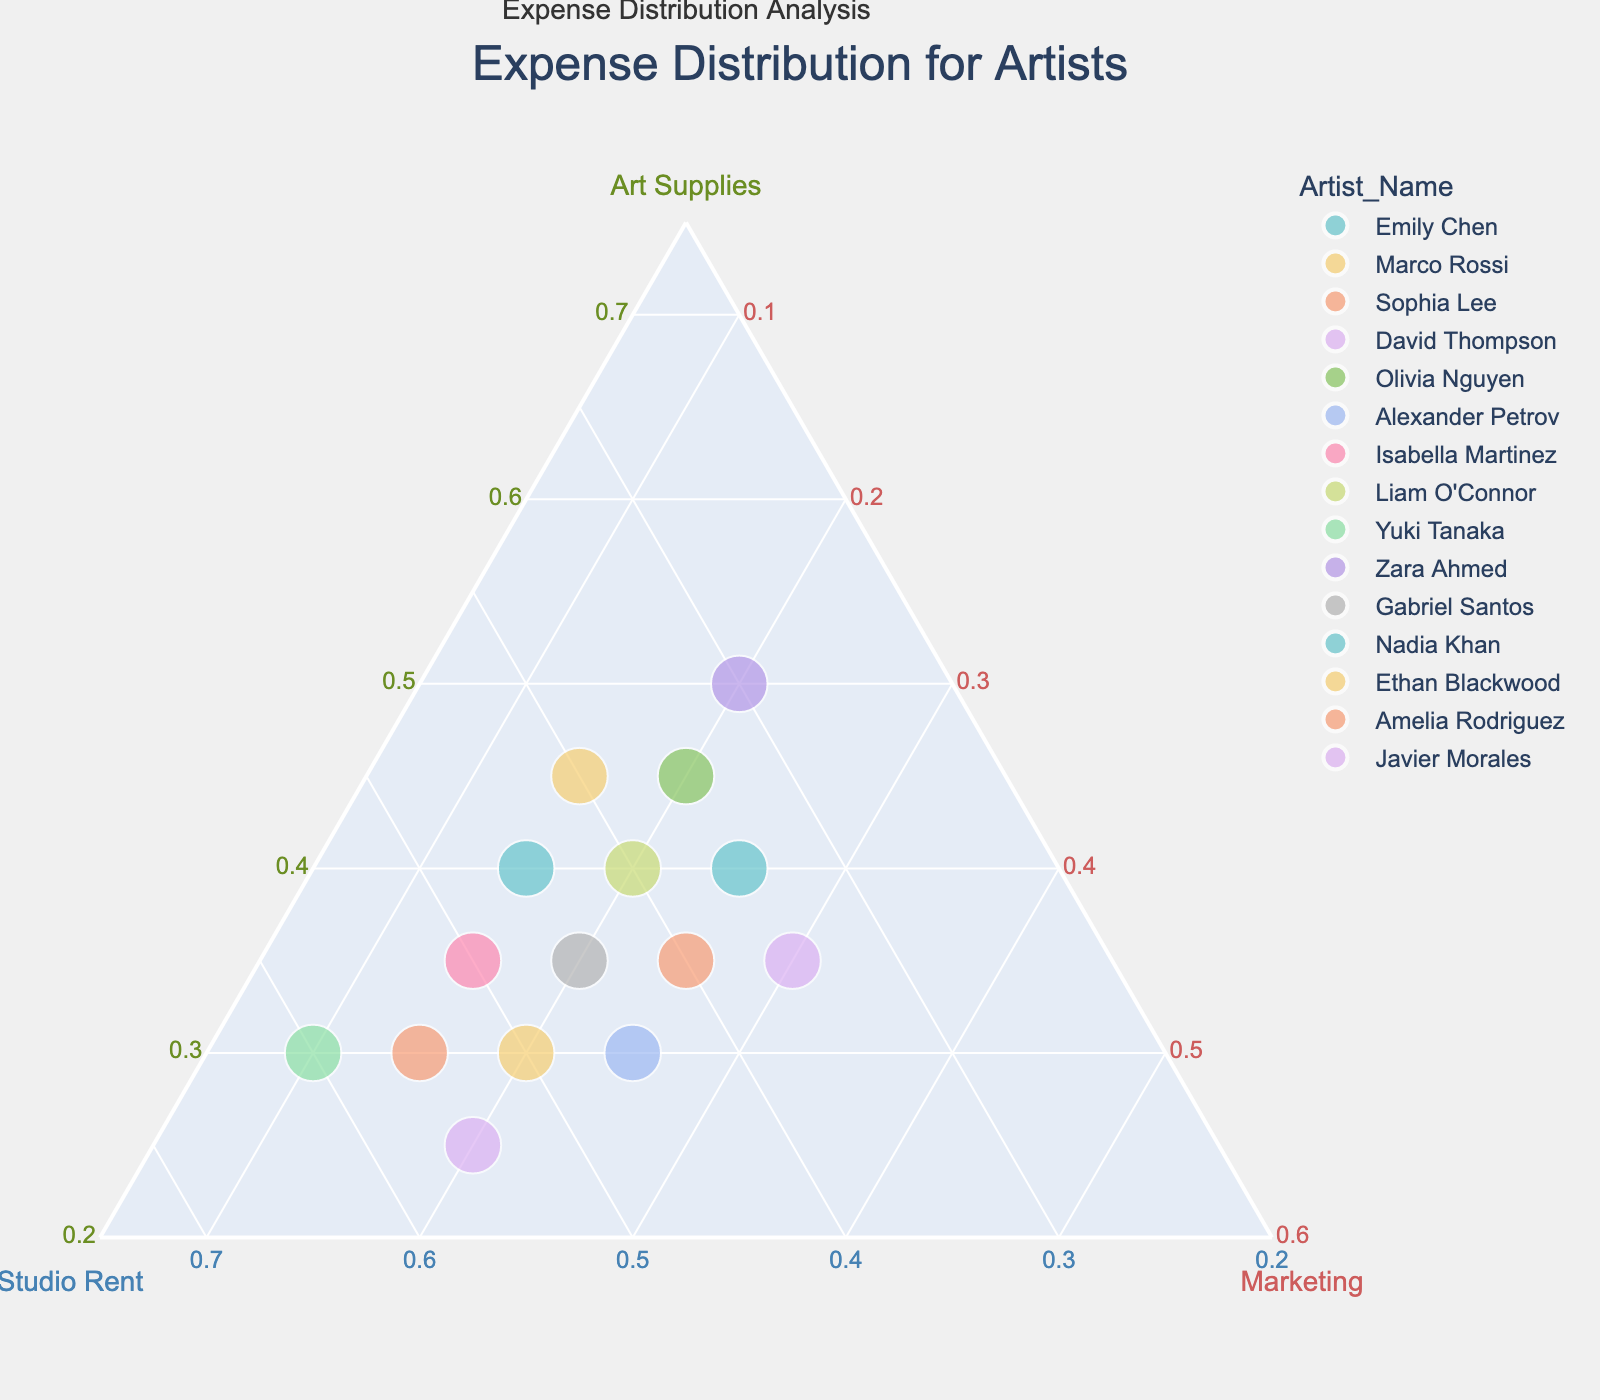How many data points are displayed in the ternary plot? Count each artist's name appearing on hover, which matches the total data points in the dataset given.
Answer: 15 What is the proportion of studio rent for Emily Chen in the expense distribution? Find the value corresponding to Studio Rent for Emily Chen, which is 45%, as shown on the plot.
Answer: 45% Which artist has the highest expense on art supplies? Search for the highest value in the Art Supplies part of the plot, identifying Zara Ahmed with 50%.
Answer: Zara Ahmed Whose marketing expenses are equal to their art supplies expenses? Compare values in the Marketing and Art Supplies parts for equality; Javier Morales and Gabriel Santos both have equal proportions of 35%.
Answer: Javier Morales, Gabriel Santos What is the difference in studio rent expenses between Marco Rossi and Amelia Rodriguez? Marco Rossi's studio rent is 50%, Amelia Rodriguez's studio rent is 55%, so compute the difference: 55% - 50%.
Answer: 5% Is there any artist with the same distribution for studio rent and marketing? Compare values for Studio Rent and Marketing for equality; no artist has identical values for these expenses.
Answer: No Which artists have more expenses in marketing compared to studio rent? Compare values in the Marketing part to the Studio Rent part to identify: Sophia Lee (25% > 20%), Nadia Khan (25% > 20%), and Javier Morales (30% > 35%).
Answer: Sophia Lee, Nadia Khan, Javier Morales What is the total proportion of art supplies and marketing costs for Alexander Petrov? Add the proportions: Art Supplies (30%) + Marketing (25%) = 55%.
Answer: 55% Who spends the least on marketing? Identify the lowest value in the Marketing part, which is 10% for Yuki Tanaka.
Answer: Yuki Tanaka What is the average proportion of studio rent for all artists? Sum all studio rent percentages and then divide by the number of artists: (45 + 50 + 40 + 55 + 35 + 45 + 50 + 40 + 60 + 30 + 45 + 35 + 40 + 55 + 35) / 15 = 44.67%.
Answer: 44.67% 